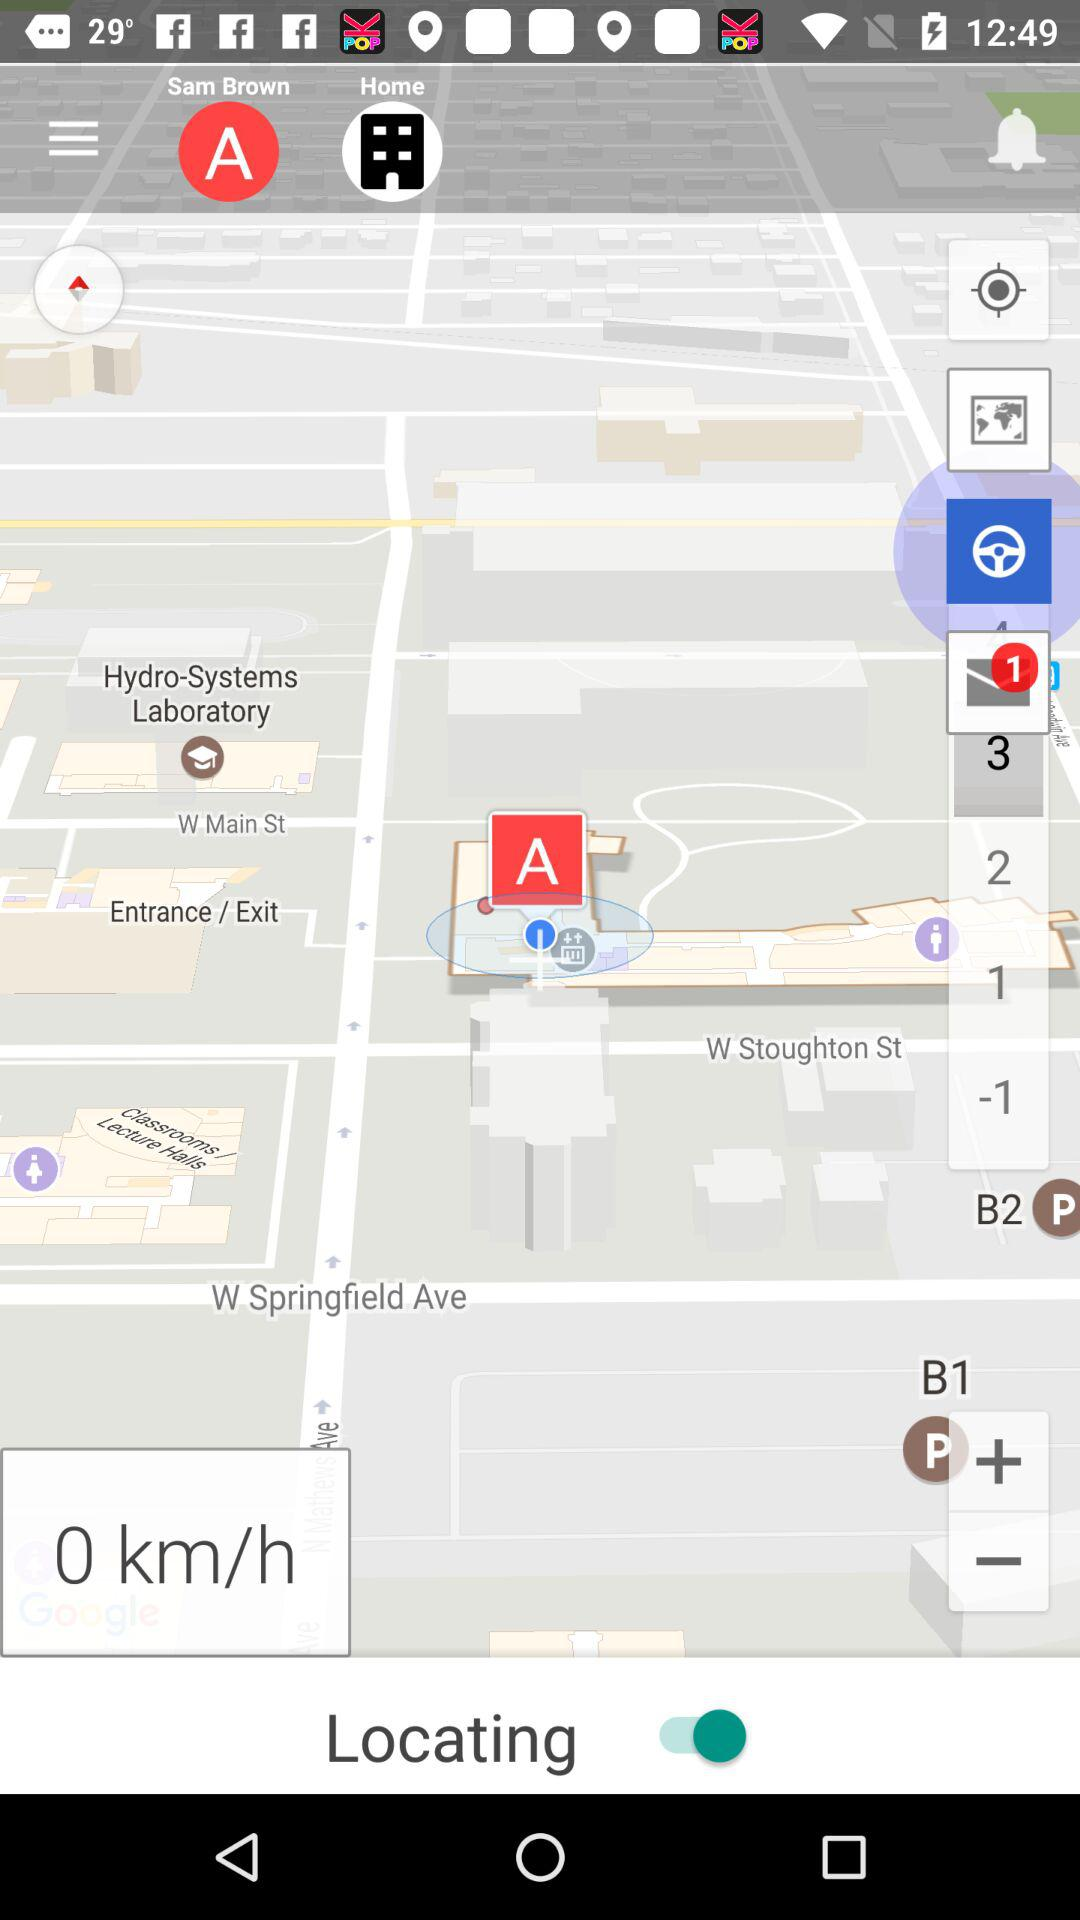How many mails are unread? There is 1 unread mail. 